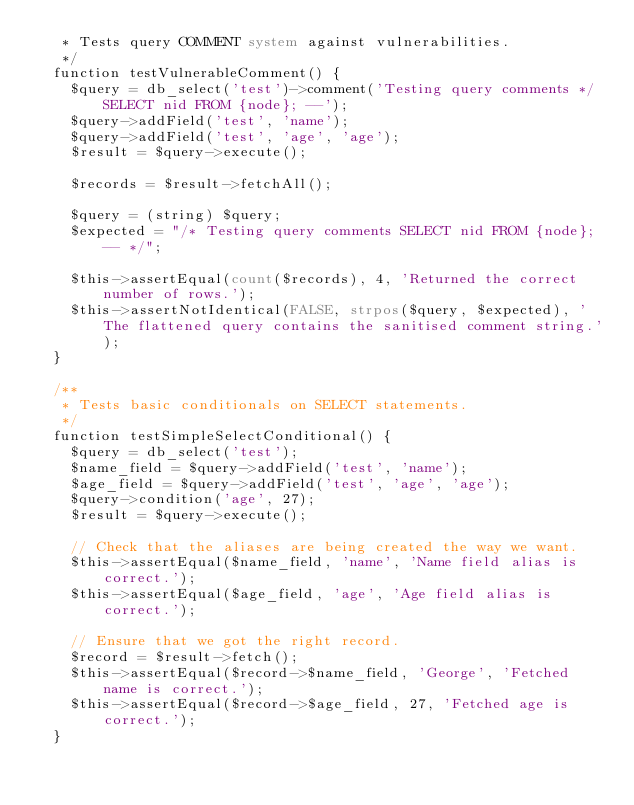<code> <loc_0><loc_0><loc_500><loc_500><_PHP_>   * Tests query COMMENT system against vulnerabilities.
   */
  function testVulnerableComment() {
    $query = db_select('test')->comment('Testing query comments */ SELECT nid FROM {node}; --');
    $query->addField('test', 'name');
    $query->addField('test', 'age', 'age');
    $result = $query->execute();

    $records = $result->fetchAll();

    $query = (string) $query;
    $expected = "/* Testing query comments SELECT nid FROM {node}; -- */";

    $this->assertEqual(count($records), 4, 'Returned the correct number of rows.');
    $this->assertNotIdentical(FALSE, strpos($query, $expected), 'The flattened query contains the sanitised comment string.');
  }

  /**
   * Tests basic conditionals on SELECT statements.
   */
  function testSimpleSelectConditional() {
    $query = db_select('test');
    $name_field = $query->addField('test', 'name');
    $age_field = $query->addField('test', 'age', 'age');
    $query->condition('age', 27);
    $result = $query->execute();

    // Check that the aliases are being created the way we want.
    $this->assertEqual($name_field, 'name', 'Name field alias is correct.');
    $this->assertEqual($age_field, 'age', 'Age field alias is correct.');

    // Ensure that we got the right record.
    $record = $result->fetch();
    $this->assertEqual($record->$name_field, 'George', 'Fetched name is correct.');
    $this->assertEqual($record->$age_field, 27, 'Fetched age is correct.');
  }
</code> 